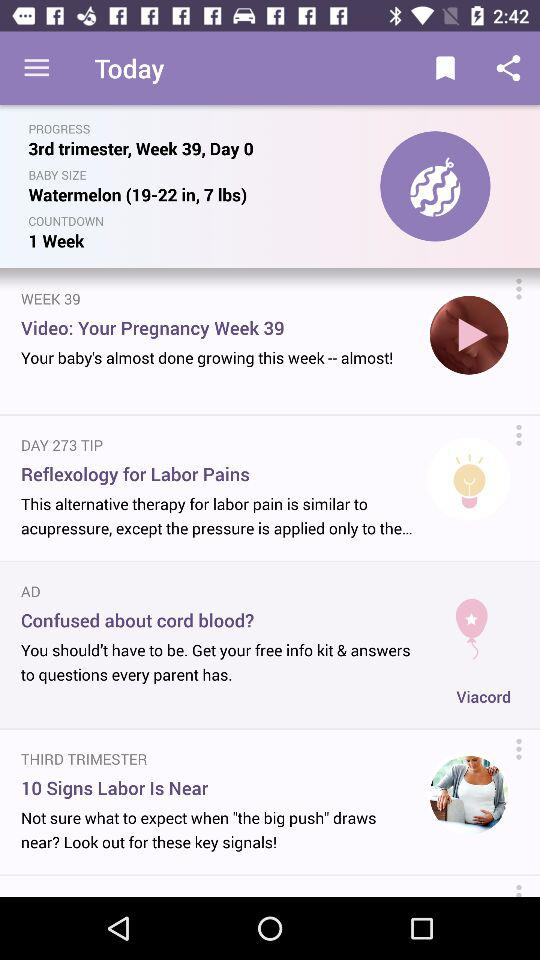What is the baby size? The baby size is watermelon (19-22 inches). 